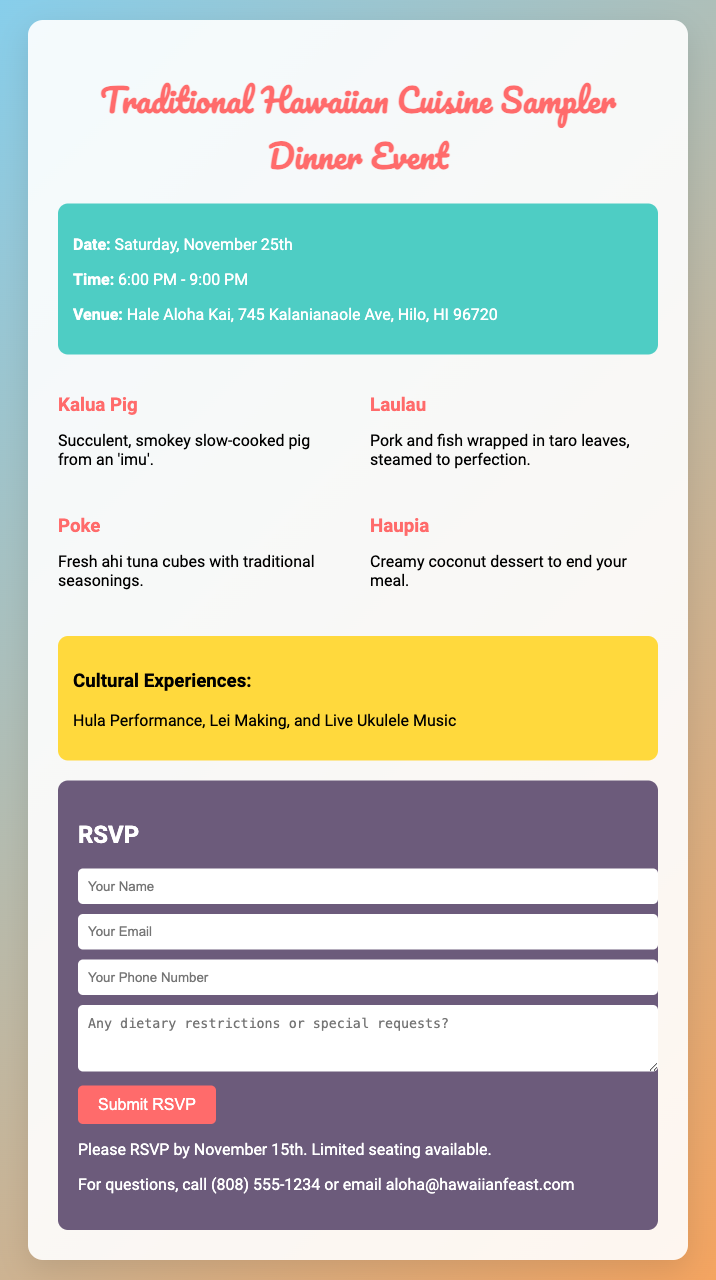What is the date of the event? The event date is clearly stated in the document as Saturday, November 25th.
Answer: Saturday, November 25th What time does the event start? The starting time of the event is mentioned in the document as 6:00 PM - 9:00 PM.
Answer: 6:00 PM Where is the venue located? The venue information is given in the document as Hale Aloha Kai, 745 Kalanianaole Ave, Hilo, HI 96720.
Answer: Hale Aloha Kai, 745 Kalanianaole Ave, Hilo, HI 96720 What dish consists of pork and fish wrapped in taro leaves? The dish described in the document that includes pork and fish wrapped in taro leaves is called Laulau.
Answer: Laulau What dessert is served at the event? The dessert mentioned in the document as ending the meal is Haupia, a creamy coconut dessert.
Answer: Haupia What must be submitted by November 15th? The document specifies that an RSVP needs to be submitted by this date for attendance at the event.
Answer: RSVP What cultural experience involves music? The cultural experience that includes music is live Ukulele music as stated in the document.
Answer: Live Ukulele Music How can we contact for questions? The contact method for questions provided in the document is via phone call or email as stated.
Answer: (808) 555-1234 or aloha@hawaiianfeast.com 